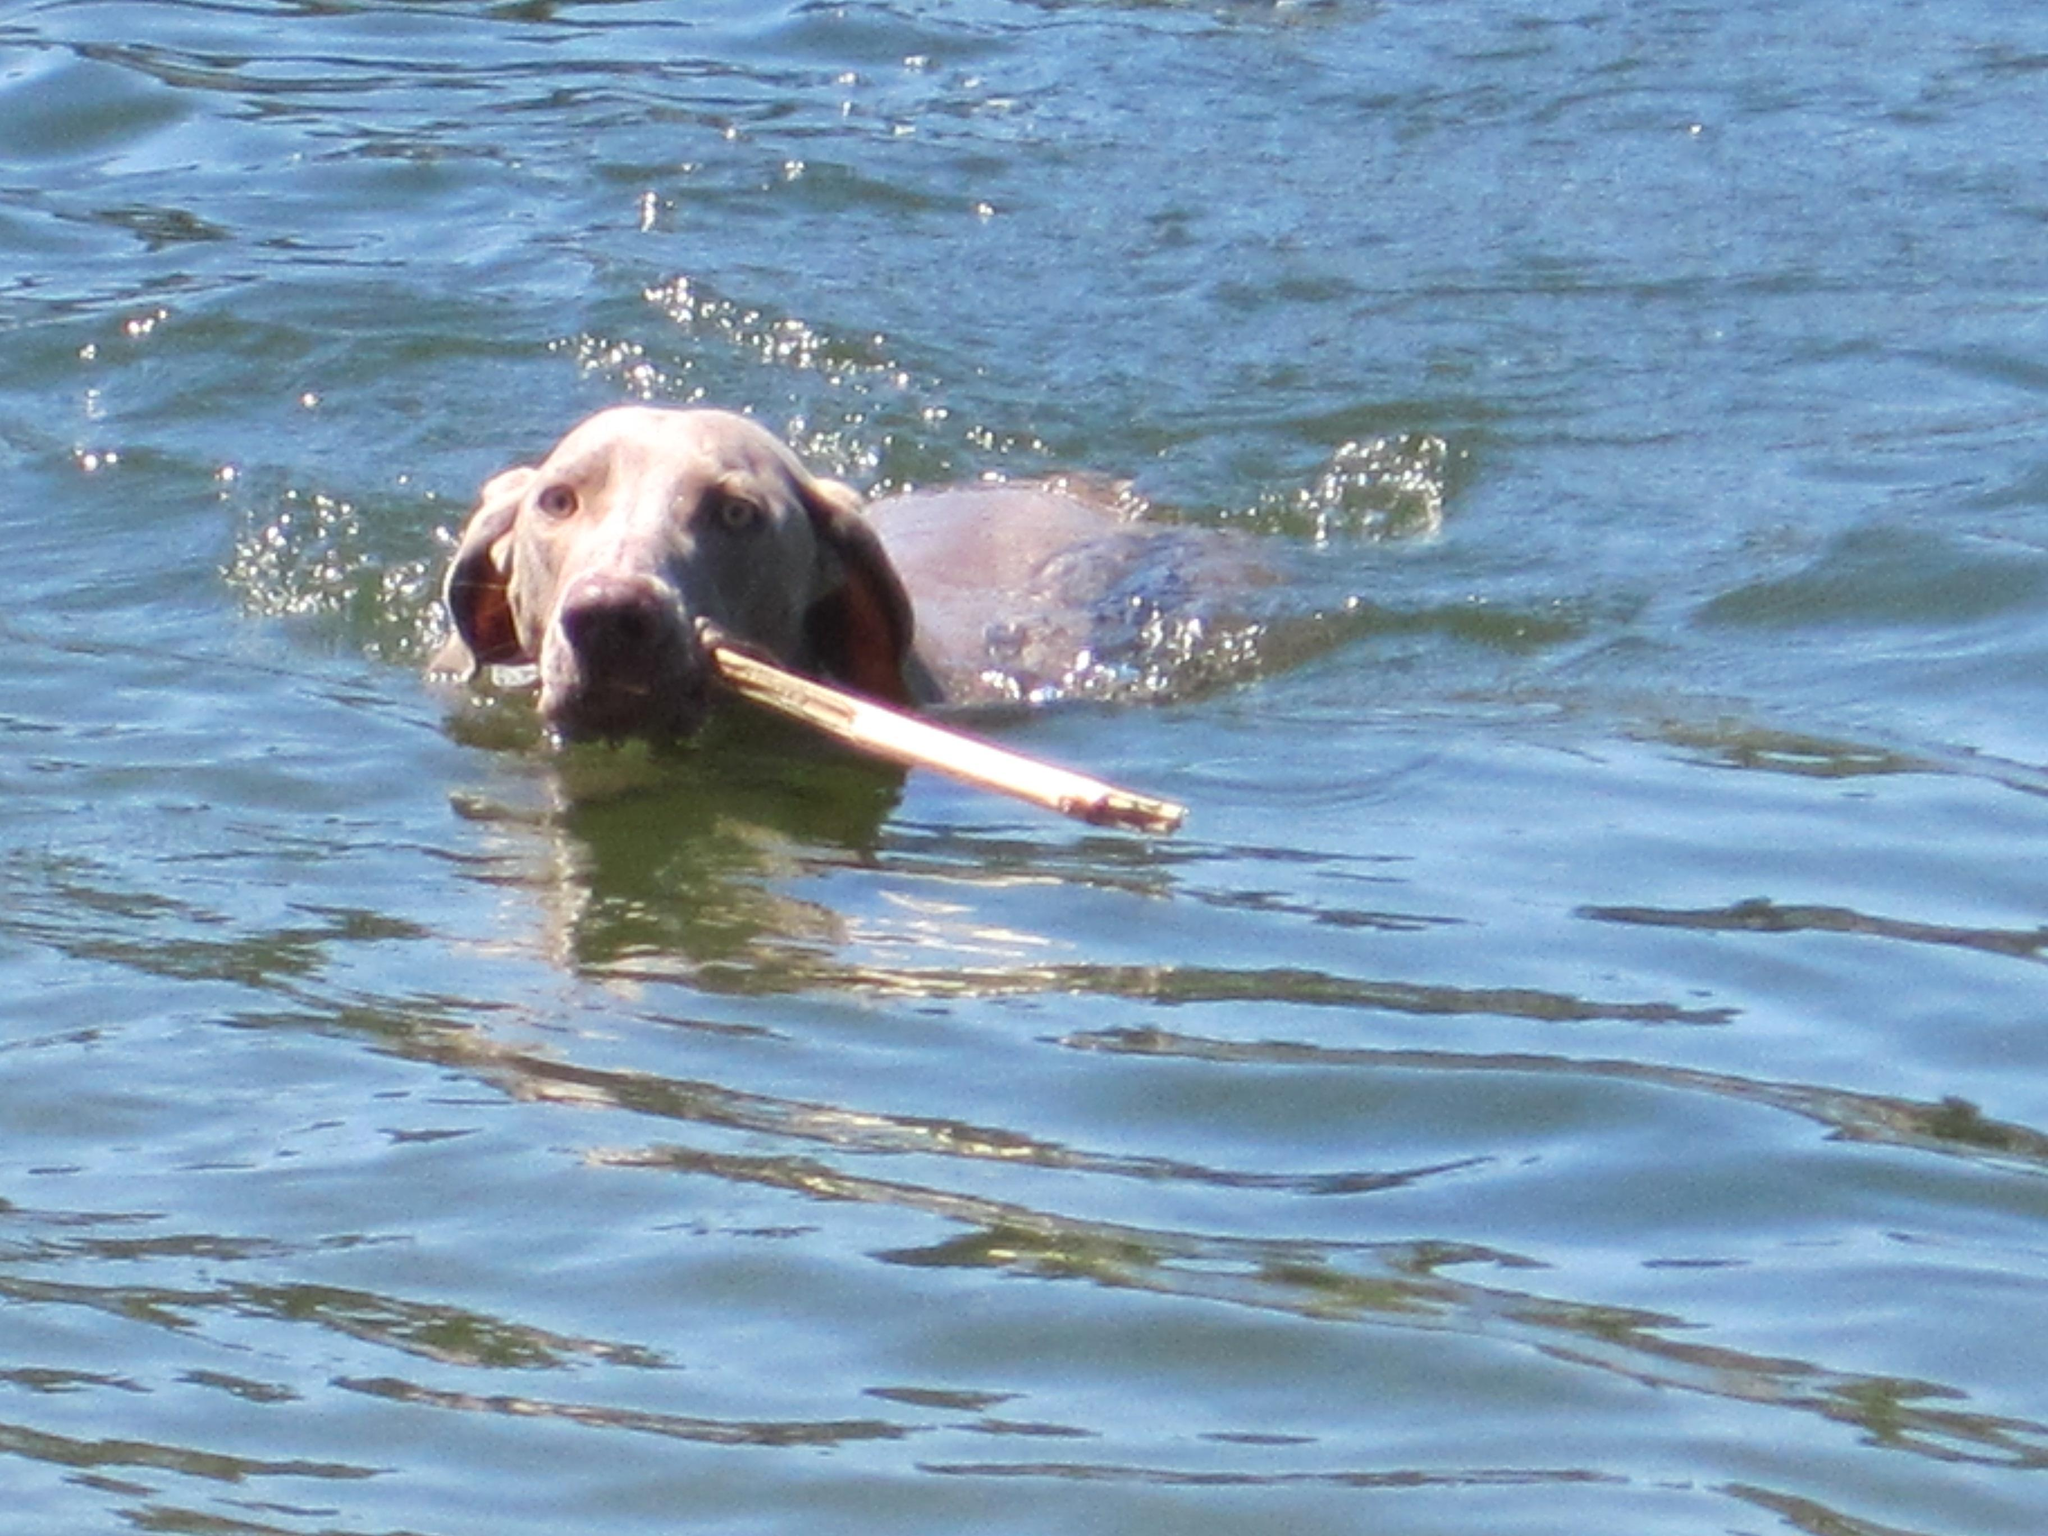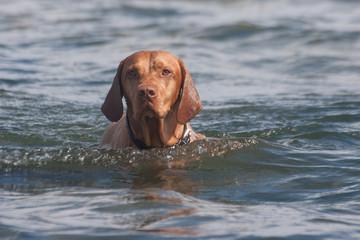The first image is the image on the left, the second image is the image on the right. Evaluate the accuracy of this statement regarding the images: "The right image contains one dog that is partially submerged in water.". Is it true? Answer yes or no. Yes. The first image is the image on the left, the second image is the image on the right. Analyze the images presented: Is the assertion "The combined images include a dog in the water and a dog moving forward while carrying something in its mouth." valid? Answer yes or no. Yes. 